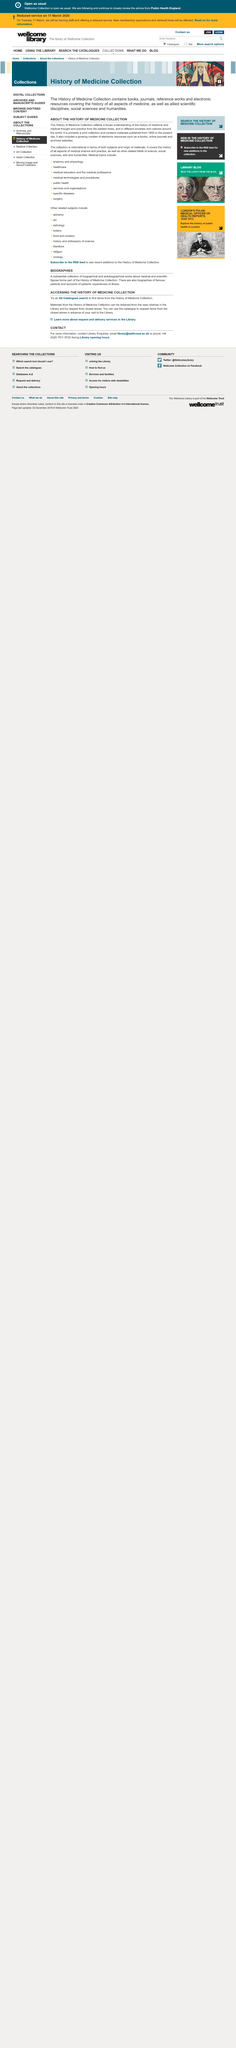List a handful of essential elements in this visual. You can use the catalog to request items from closed stores in advance of your visit to the library. The History of Medicine Collection is primarily composed of print materials, but it also includes a growing number of electronic resources. The History of Medicine Collection is accessible through open shelves in the library and by request from closed storage. The History of Medicine Collection includes a substantial collection of biographical and autobiographical works that provide information about medical and scientific figures. The History of Medicine Collection encompasses the history of all aspects of medical science and practice, as well as related fields of science, social sciences, arts, and humanities. 